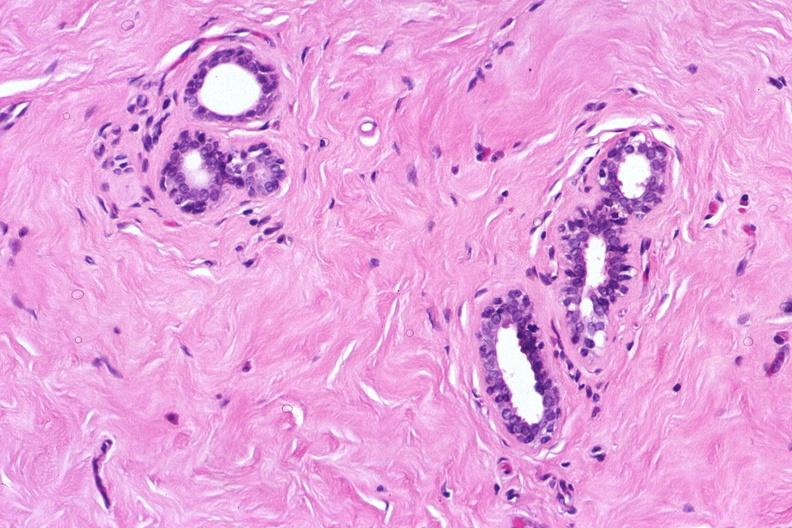where is this from?
Answer the question using a single word or phrase. Female reproductive system 